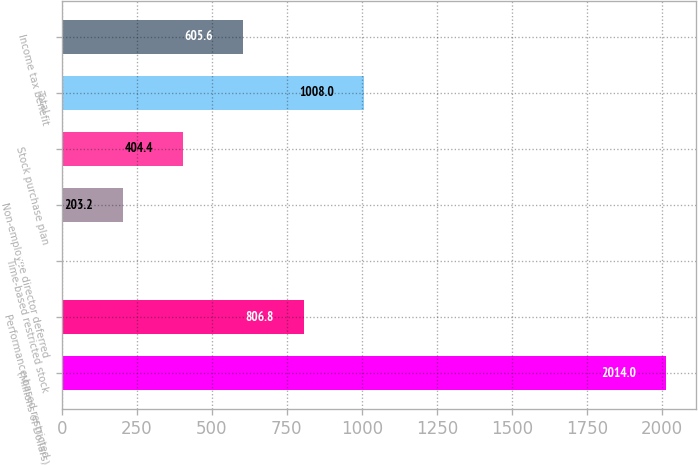Convert chart. <chart><loc_0><loc_0><loc_500><loc_500><bar_chart><fcel>(Millions of Dollars)<fcel>Performance-based restricted<fcel>Time-based restricted stock<fcel>Non-employee director deferred<fcel>Stock purchase plan<fcel>Total<fcel>Income tax benefit<nl><fcel>2014<fcel>806.8<fcel>2<fcel>203.2<fcel>404.4<fcel>1008<fcel>605.6<nl></chart> 